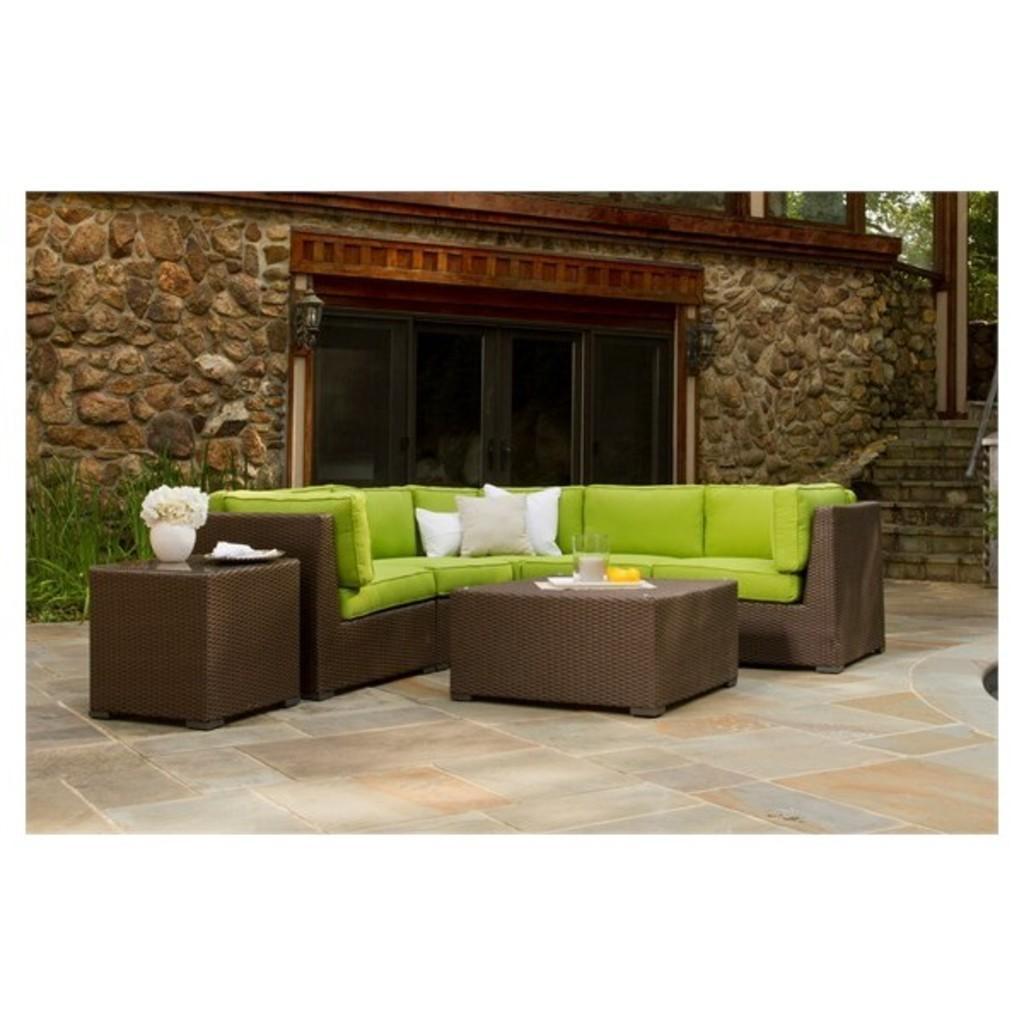Could you give a brief overview of what you see in this image? In this picture we can see a flower vase on the table and also we can see a sofa, wall, light and couple of plants. 